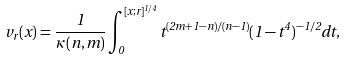<formula> <loc_0><loc_0><loc_500><loc_500>v _ { r } ( x ) = \frac { 1 } { \kappa ( n , m ) } \int _ { 0 } ^ { [ x ; r ] ^ { 1 / 4 } } t ^ { ( 2 m + 1 - n ) / ( n - 1 ) } ( 1 - t ^ { 4 } ) ^ { - 1 / 2 } d t ,</formula> 